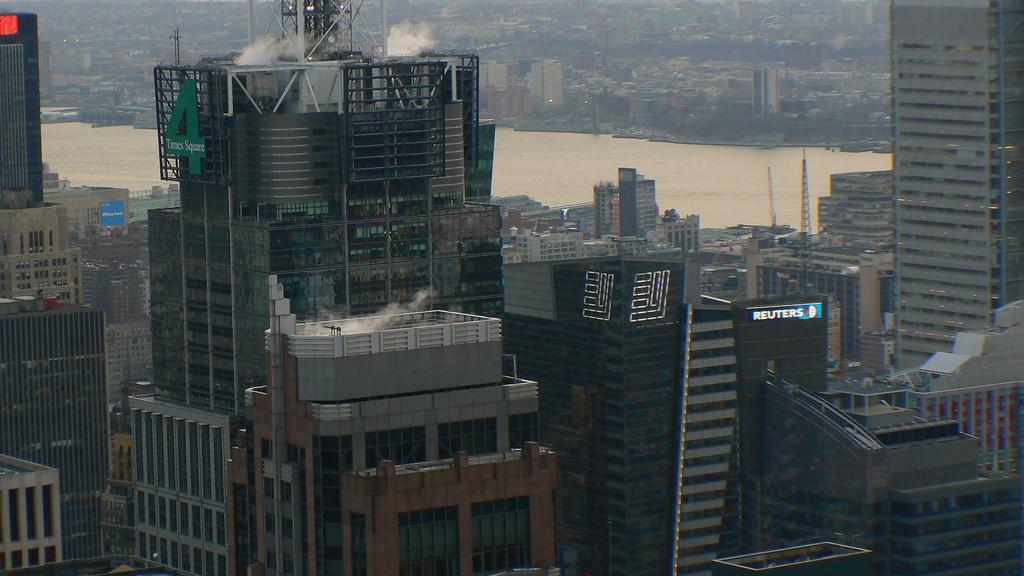What structures are present in the image? There are buildings in the image. What natural feature can be seen behind the buildings? There is a river flowing behind the buildings. What is visible at the top of the image? There is smoke visible at the top of the image. What type of hands can be seen holding the frame of the image? There are no hands or frames present in the image; it is a photograph or illustration of buildings, a river, and smoke. 